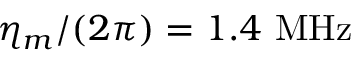Convert formula to latex. <formula><loc_0><loc_0><loc_500><loc_500>\eta _ { m } / ( 2 \pi ) = 1 . 4 M H z</formula> 